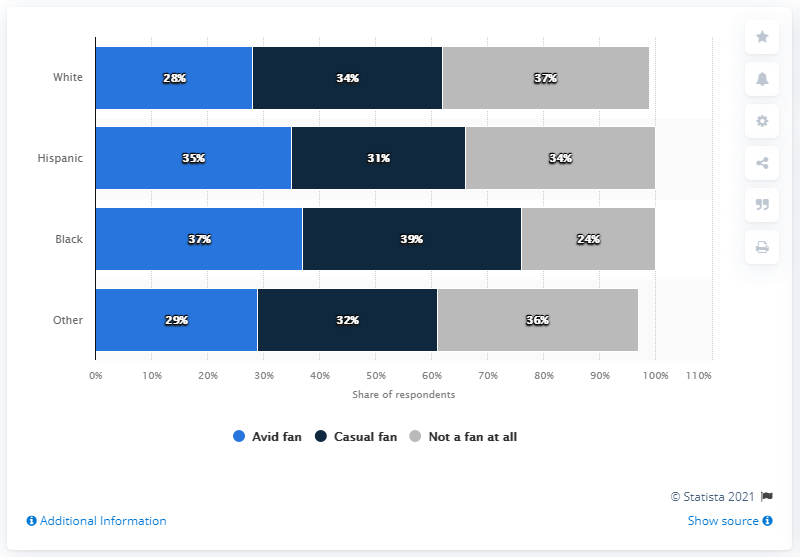Outline some significant characteristics in this image. According to a survey conducted in June 2021, 37% of Black respondents were avid fans of the NFL. 